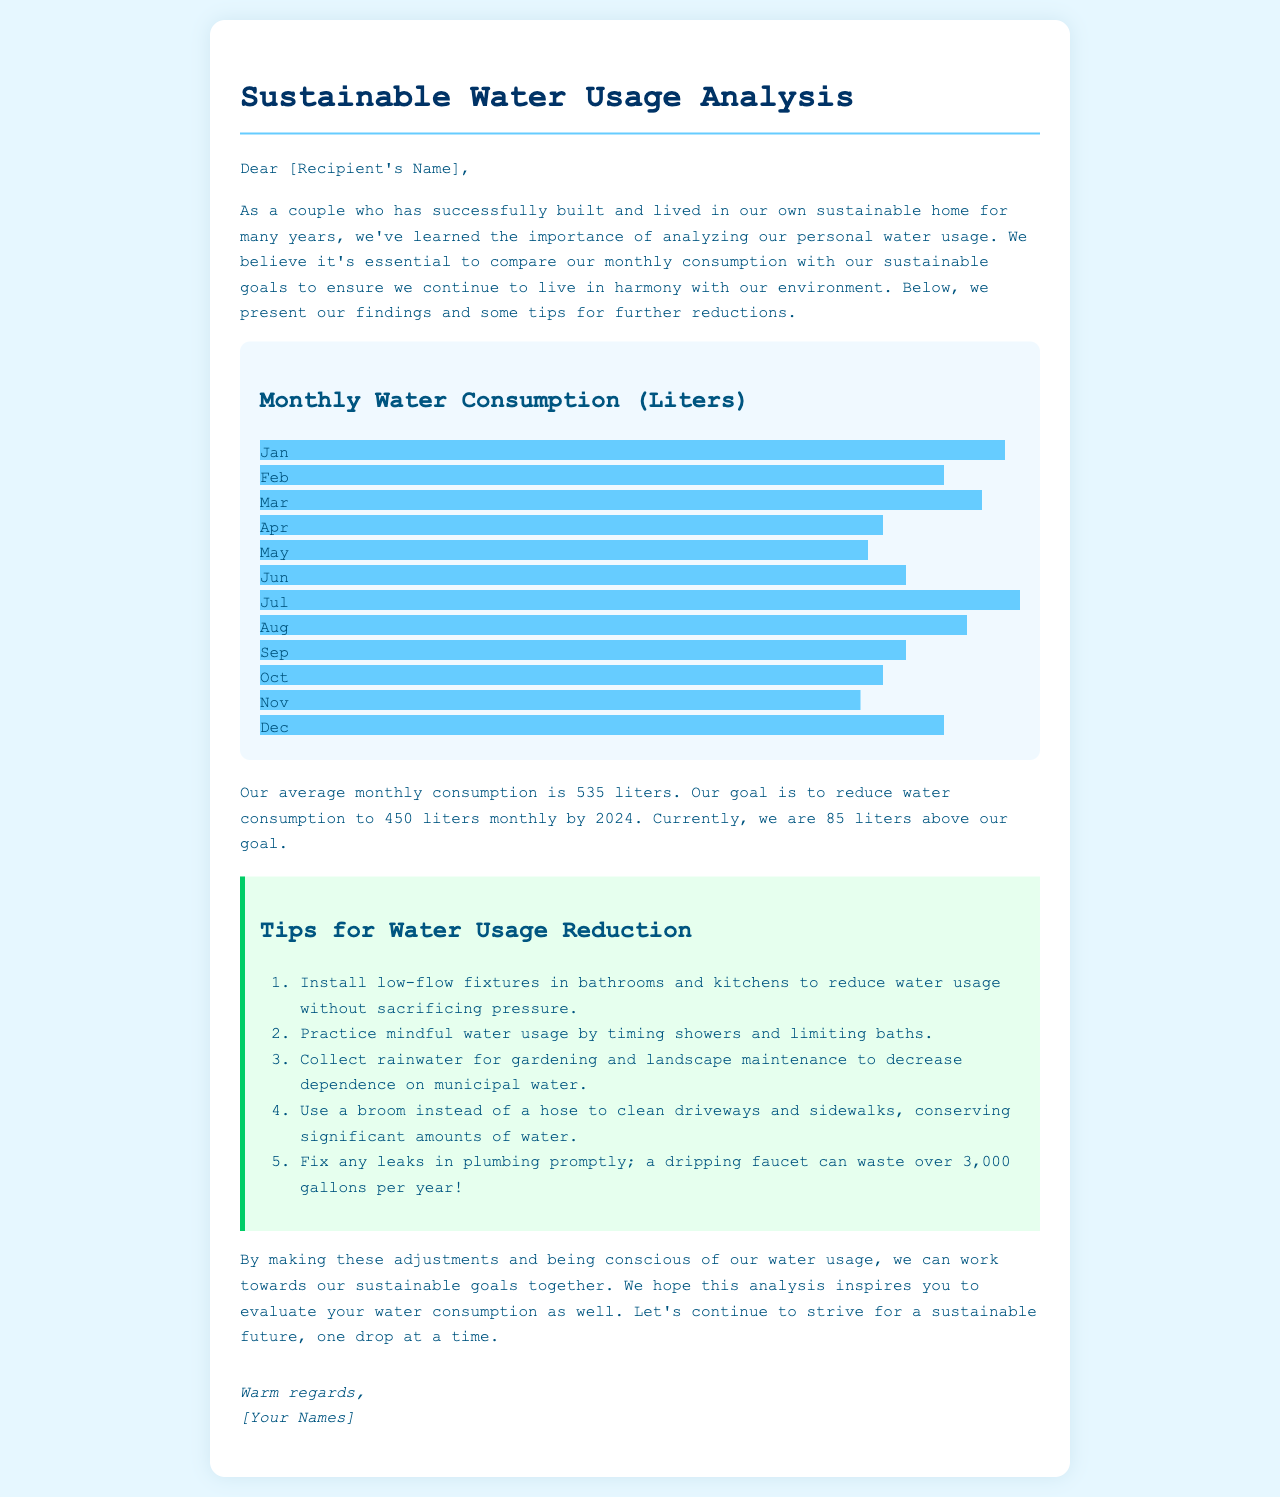What is the monthly water consumption goal? The document states the goal is to reduce water consumption to 450 liters monthly by 2024.
Answer: 450 liters What was the average monthly consumption? According to the document, the average monthly consumption is 535 liters.
Answer: 535 liters In which month did the couple consume 610 liters? The document mentions that 610 liters were consumed in July.
Answer: July How much water consumption did the couple exceed their goal by? The couple is currently 85 liters above their goal of 450 liters.
Answer: 85 liters Which month had the least water consumption? The document states that November had the least water consumption at 480 liters.
Answer: November What is a tip for reducing water usage related to bathrooms? The document recommends installing low-flow fixtures in bathrooms and kitchens.
Answer: Install low-flow fixtures Which month had the highest consumption according to the chart? The highest consumption was in July at 610 liters as noted in the chart.
Answer: July How many gallons can a dripping faucet waste per year? The document states that a dripping faucet can waste over 3,000 gallons per year.
Answer: 3,000 gallons What is the purpose of the letter? The purpose is to analyze personal water usage and offer tips for reduction.
Answer: Analyze personal water usage 